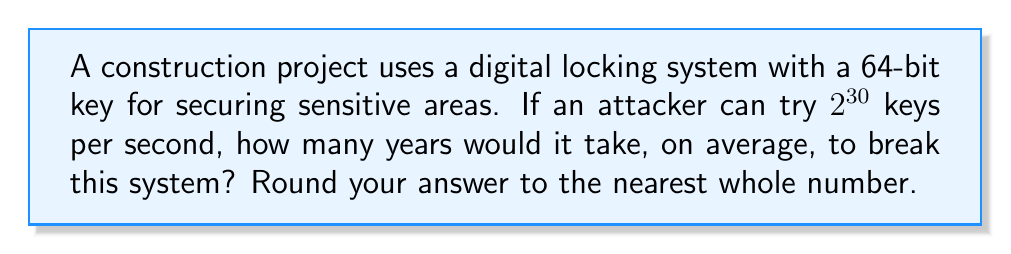Can you answer this question? To solve this problem, we'll follow these steps:

1) The total number of possible keys in a 64-bit system is $2^{64}$.

2) On average, an attacker would need to try half of all possible keys before finding the correct one. So, the expected number of attempts is:

   $\frac{2^{64}}{2} = 2^{63}$

3) The attacker can try $2^{30}$ keys per second. To find the number of seconds needed, we divide the number of attempts by the attack rate:

   $\frac{2^{63}}{2^{30}} = 2^{33}$ seconds

4) To convert this to years, we need to divide by the number of seconds in a year:
   
   Seconds in a year = 365.25 * 24 * 60 * 60 = 31,557,600

5) Years required:

   $\frac{2^{33}}{31,557,600} \approx 272.31$ years

6) Rounding to the nearest whole number gives us 272 years.
Answer: 272 years 